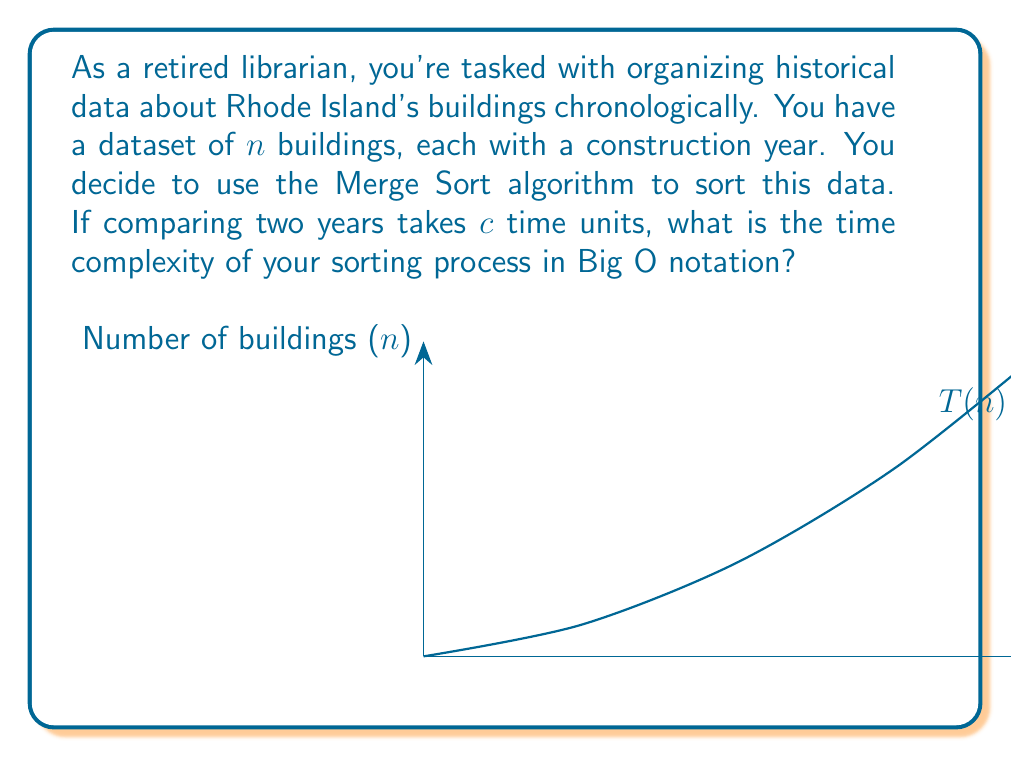What is the answer to this math problem? To determine the time complexity of Merge Sort for organizing the historical data:

1) Merge Sort divides the dataset into two halves recursively until we have single elements.

2) The number of levels in the recursion tree is $\log_2(n)$, where $n$ is the number of buildings.

3) At each level, we perform merging operations. The total number of comparisons at each level is proportional to $n$.

4) Therefore, the total number of comparisons is proportional to $n \log_2(n)$.

5) Each comparison takes $c$ time units.

6) The total time is thus proportional to $cn \log_2(n)$.

7) In Big O notation, we drop constant factors. So, $c$ is omitted.

8) The base of the logarithm doesn't affect the asymptotic complexity, so we can write it as just $\log n$.

Therefore, the time complexity of Merge Sort for organizing the historical building data is $O(n \log n)$.
Answer: $O(n \log n)$ 